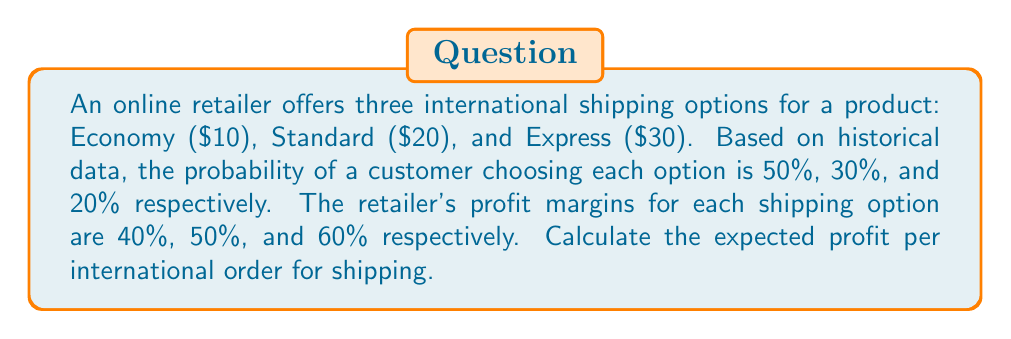Show me your answer to this math problem. Let's approach this step-by-step:

1) First, we need to calculate the profit for each shipping option:

   Economy: $10 * 40% = $4
   Standard: $20 * 50% = $10
   Express: $30 * 60% = $18

2) Now, we have the following scenario:
   - Economy shipping: 50% chance, $4 profit
   - Standard shipping: 30% chance, $10 profit
   - Express shipping: 20% chance, $18 profit

3) The expected value (EV) is calculated by multiplying each outcome by its probability and then summing these products. Let's use the formula:

   $$EV = \sum_{i=1}^{n} p_i * x_i$$

   Where $p_i$ is the probability of each outcome and $x_i$ is the value of each outcome.

4) Plugging in our values:

   $$EV = (0.50 * 4) + (0.30 * 10) + (0.20 * 18)$$

5) Let's calculate:

   $$EV = 2 + 3 + 3.60 = 8.60$$

Therefore, the expected profit per international order for shipping is $8.60.
Answer: $8.60 